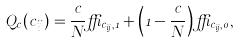<formula> <loc_0><loc_0><loc_500><loc_500>Q _ { c } ( c _ { i j } ) = \frac { c } { N } \delta _ { c _ { i j } , 1 } + \left ( 1 - \frac { c } { N } \right ) \delta _ { c _ { i j } , 0 } ,</formula> 